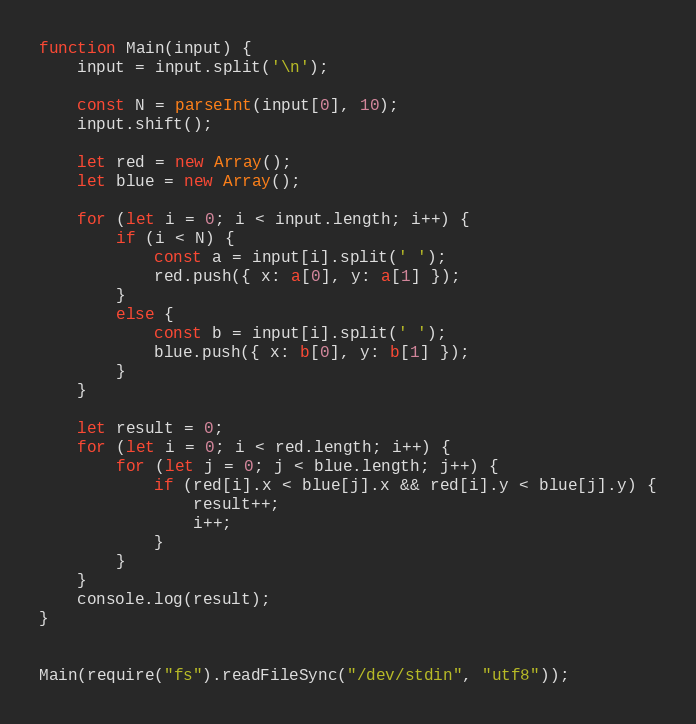Convert code to text. <code><loc_0><loc_0><loc_500><loc_500><_TypeScript_>function Main(input) {
    input = input.split('\n');

    const N = parseInt(input[0], 10);
    input.shift();

    let red = new Array();
    let blue = new Array();

    for (let i = 0; i < input.length; i++) {
        if (i < N) {
            const a = input[i].split(' ');
            red.push({ x: a[0], y: a[1] });
        }
        else {
            const b = input[i].split(' ');
            blue.push({ x: b[0], y: b[1] });
        }
    }

    let result = 0;
    for (let i = 0; i < red.length; i++) {
        for (let j = 0; j < blue.length; j++) {
            if (red[i].x < blue[j].x && red[i].y < blue[j].y) {
                result++;
                i++;
            }
        }
    }
    console.log(result);
}


Main(require("fs").readFileSync("/dev/stdin", "utf8"));</code> 